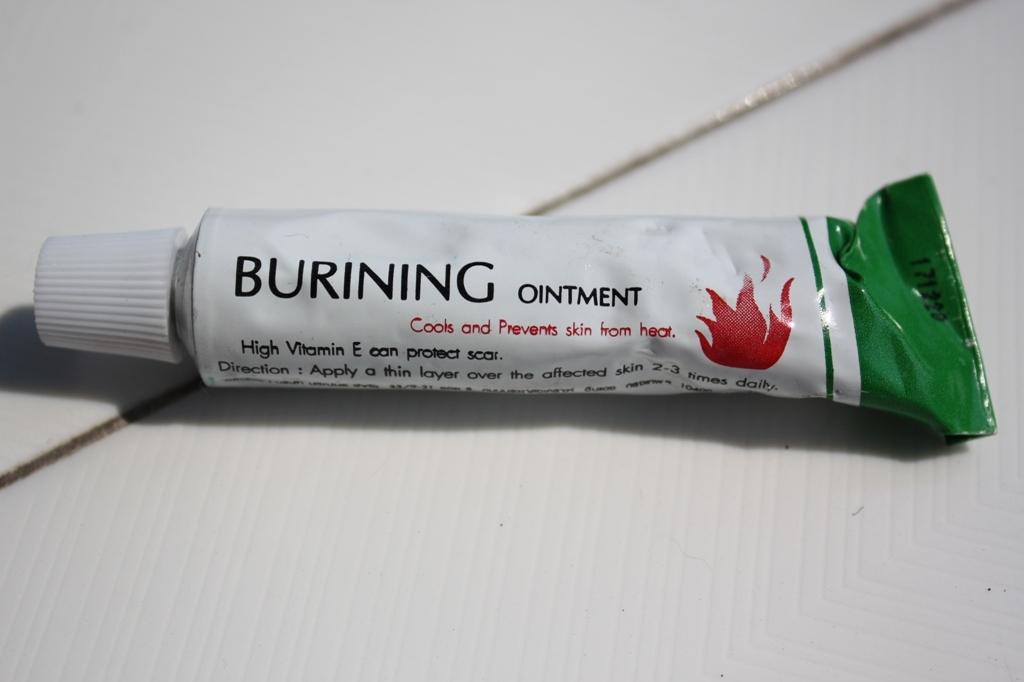What vitamin is in this ointment?
Offer a terse response. E. 